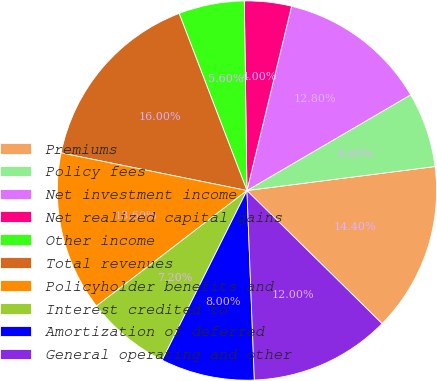<chart> <loc_0><loc_0><loc_500><loc_500><pie_chart><fcel>Premiums<fcel>Policy fees<fcel>Net investment income<fcel>Net realized capital gains<fcel>Other income<fcel>Total revenues<fcel>Policyholder benefits and<fcel>Interest credited to<fcel>Amortization of deferred<fcel>General operating and other<nl><fcel>14.4%<fcel>6.4%<fcel>12.8%<fcel>4.0%<fcel>5.6%<fcel>16.0%<fcel>13.6%<fcel>7.2%<fcel>8.0%<fcel>12.0%<nl></chart> 